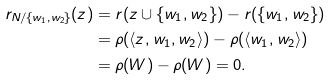Convert formula to latex. <formula><loc_0><loc_0><loc_500><loc_500>r _ { N / \{ w _ { 1 } , w _ { 2 } \} } ( z ) & = r ( z \cup \{ w _ { 1 } , w _ { 2 } \} ) - r ( \{ w _ { 1 } , w _ { 2 } \} ) \\ & = \rho ( \langle z , w _ { 1 } , w _ { 2 } \rangle ) - \rho ( \langle w _ { 1 } , w _ { 2 } \rangle ) \\ & = \rho ( W ) - \rho ( W ) = 0 .</formula> 